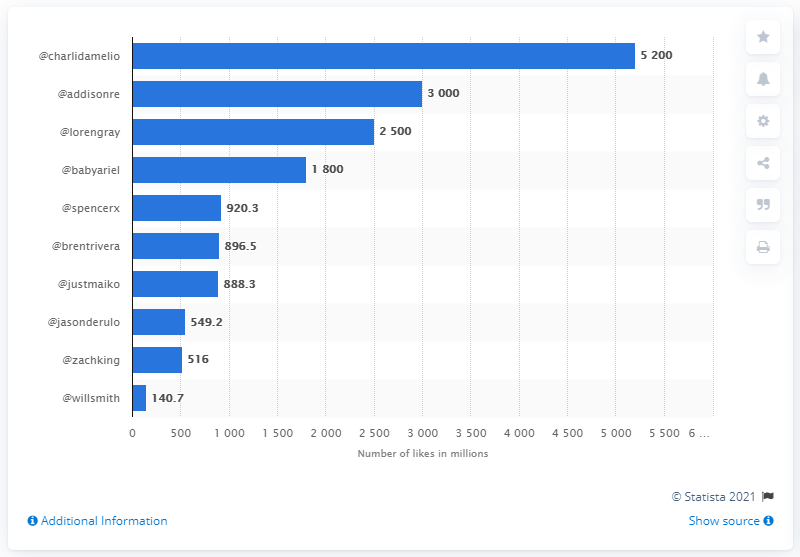Point out several critical features in this image. Charli D'Amelio had 5,200 likes on her content. 